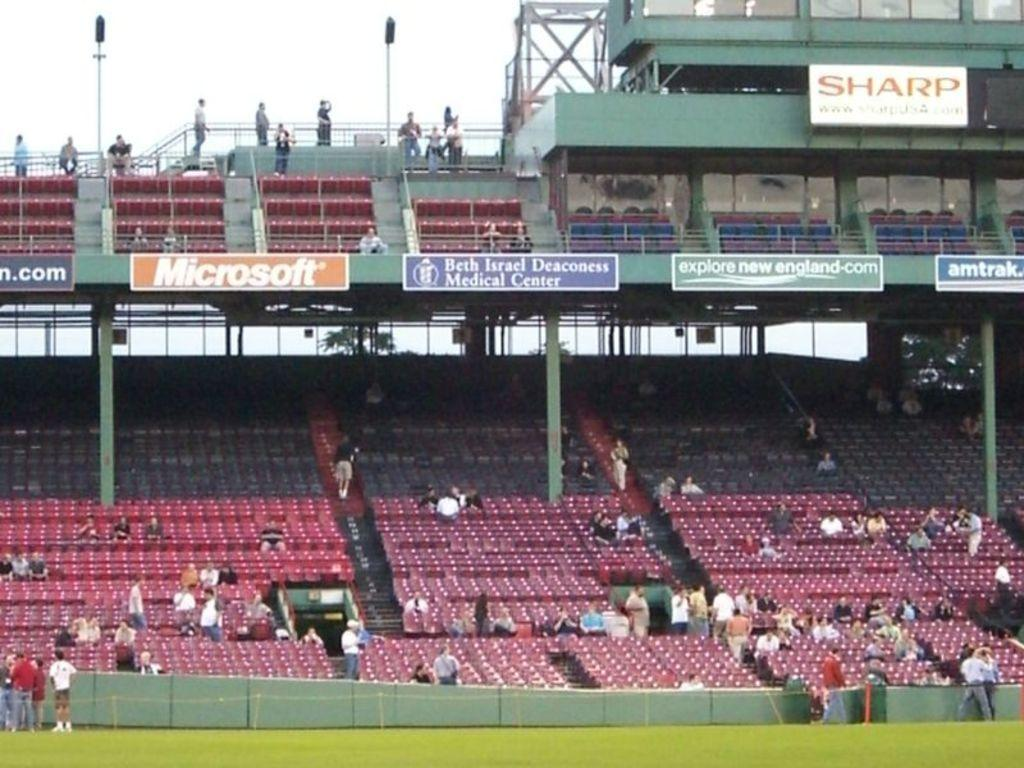Provide a one-sentence caption for the provided image. A sparsely populated stadium displays ads for Microsoft and Sharp. 